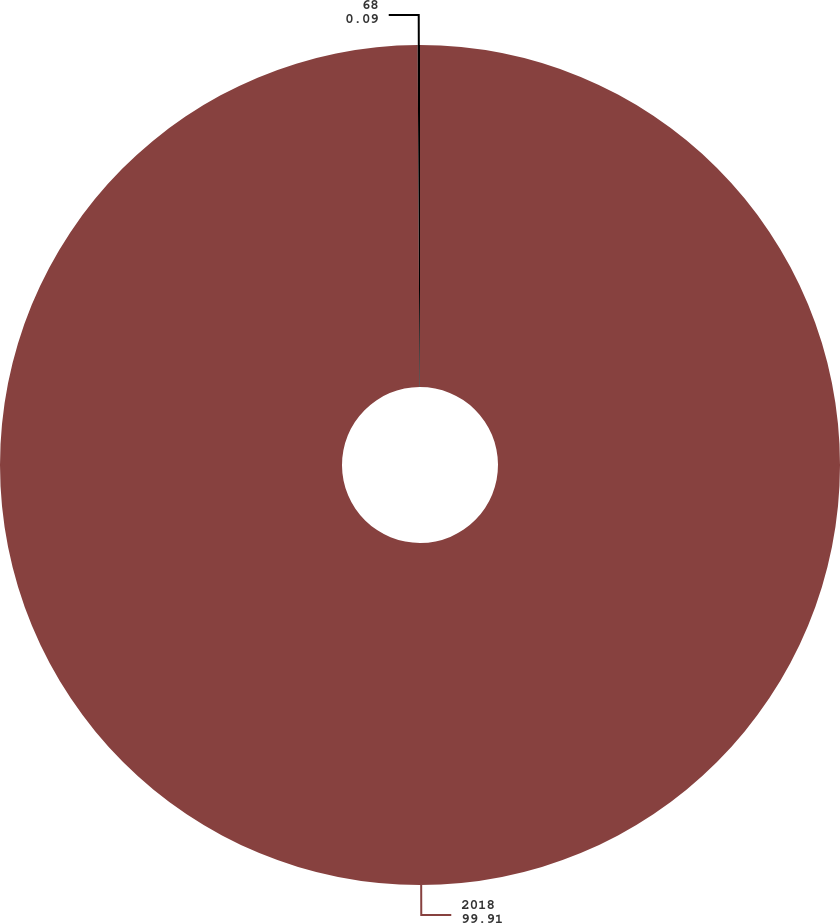<chart> <loc_0><loc_0><loc_500><loc_500><pie_chart><fcel>2018<fcel>68<nl><fcel>99.91%<fcel>0.09%<nl></chart> 